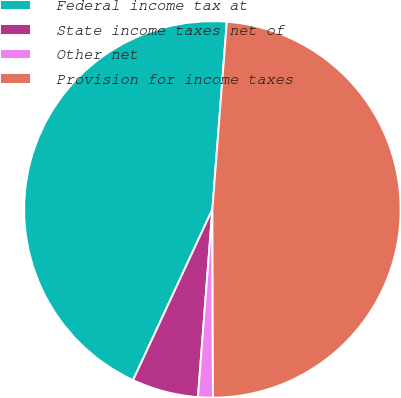<chart> <loc_0><loc_0><loc_500><loc_500><pie_chart><fcel>Federal income tax at<fcel>State income taxes net of<fcel>Other net<fcel>Provision for income taxes<nl><fcel>44.3%<fcel>5.7%<fcel>1.27%<fcel>48.73%<nl></chart> 